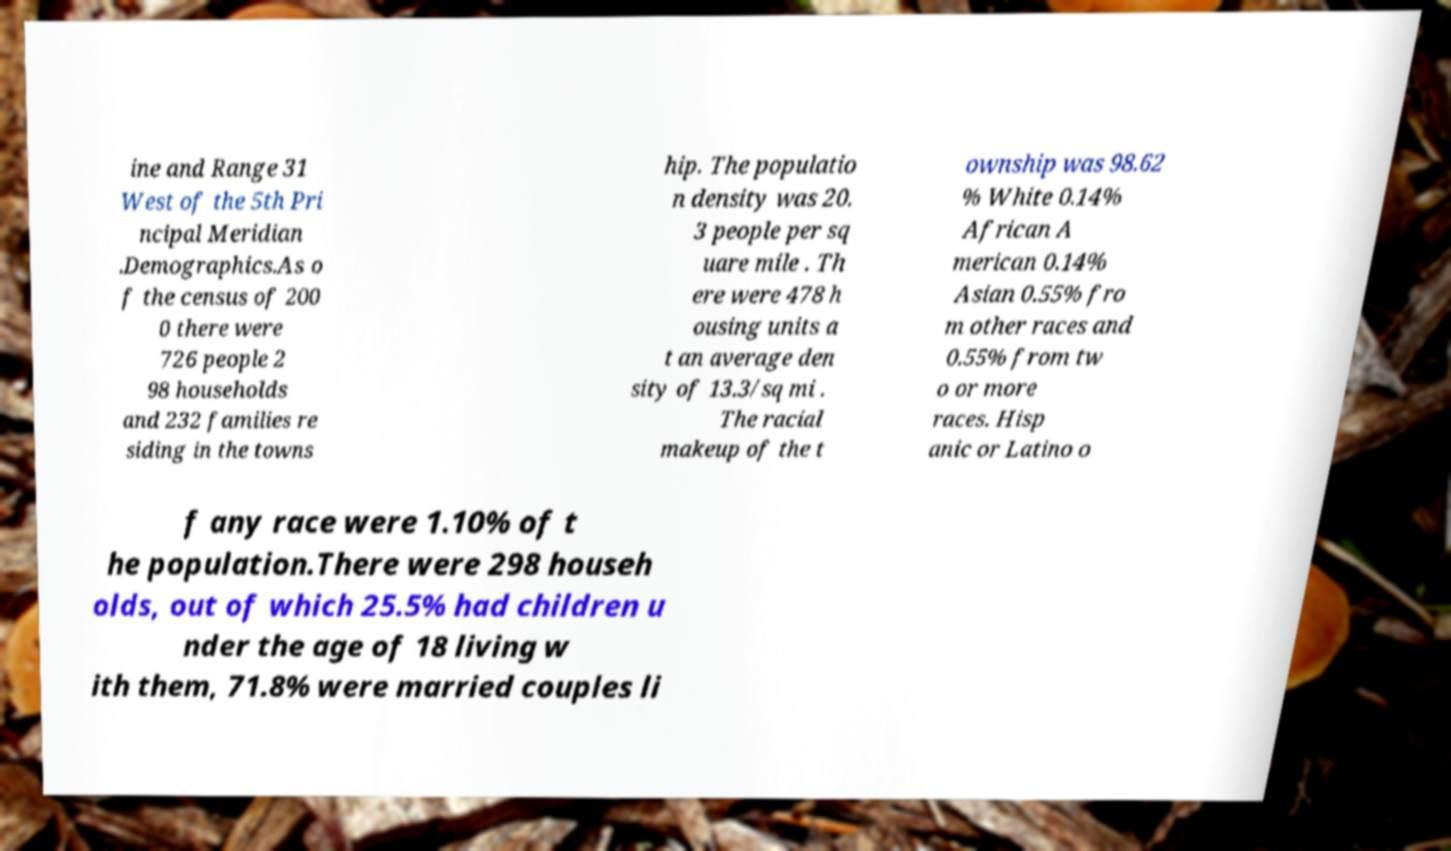Could you extract and type out the text from this image? ine and Range 31 West of the 5th Pri ncipal Meridian .Demographics.As o f the census of 200 0 there were 726 people 2 98 households and 232 families re siding in the towns hip. The populatio n density was 20. 3 people per sq uare mile . Th ere were 478 h ousing units a t an average den sity of 13.3/sq mi . The racial makeup of the t ownship was 98.62 % White 0.14% African A merican 0.14% Asian 0.55% fro m other races and 0.55% from tw o or more races. Hisp anic or Latino o f any race were 1.10% of t he population.There were 298 househ olds, out of which 25.5% had children u nder the age of 18 living w ith them, 71.8% were married couples li 